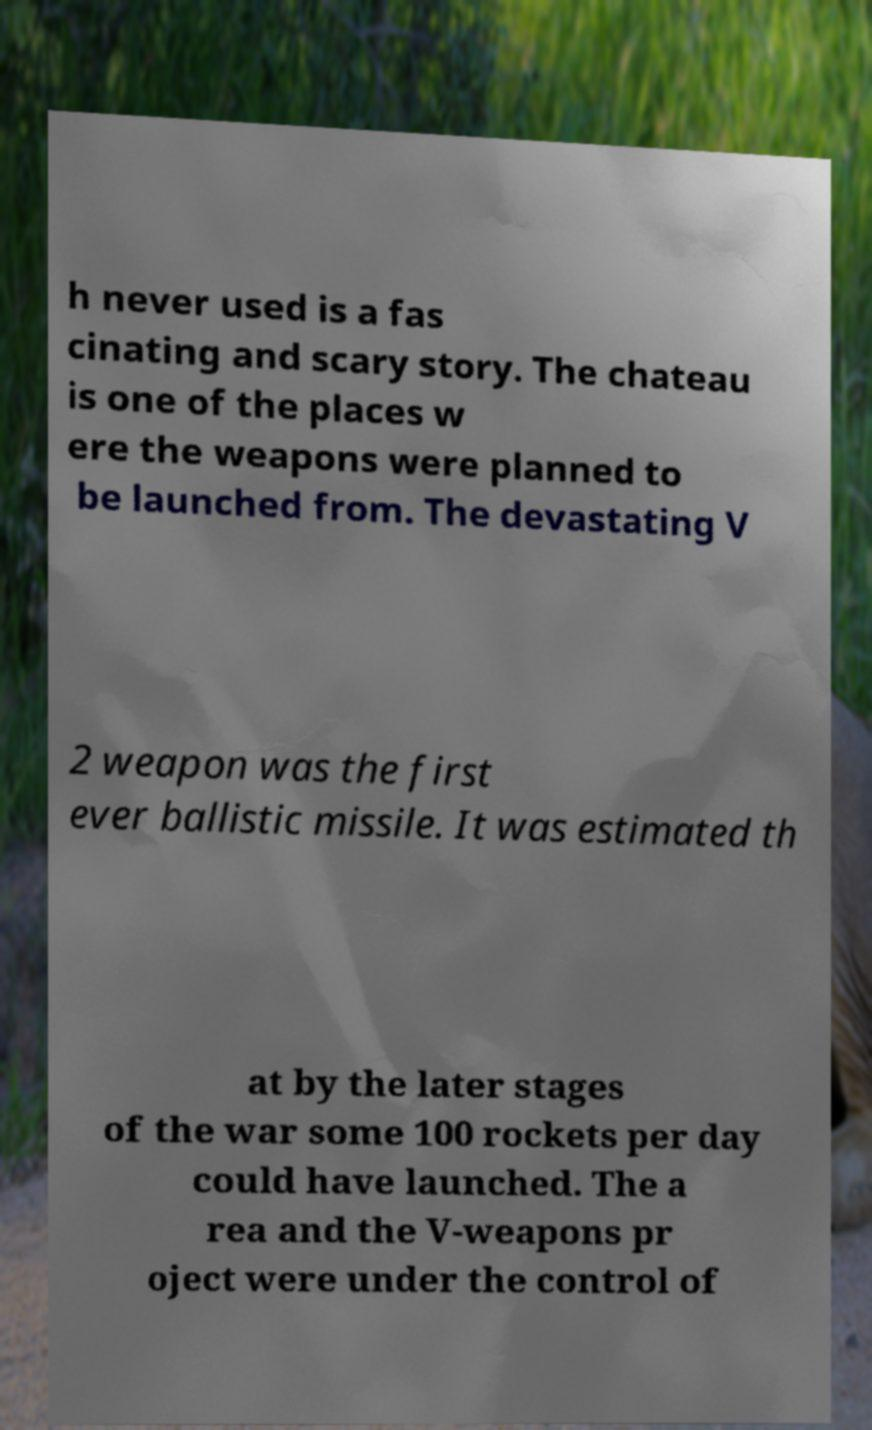Could you extract and type out the text from this image? h never used is a fas cinating and scary story. The chateau is one of the places w ere the weapons were planned to be launched from. The devastating V 2 weapon was the first ever ballistic missile. It was estimated th at by the later stages of the war some 100 rockets per day could have launched. The a rea and the V-weapons pr oject were under the control of 